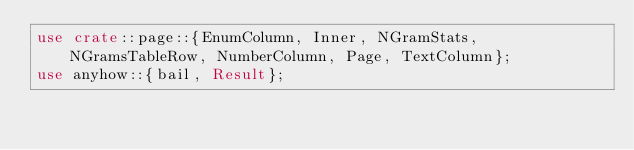Convert code to text. <code><loc_0><loc_0><loc_500><loc_500><_Rust_>use crate::page::{EnumColumn, Inner, NGramStats, NGramsTableRow, NumberColumn, Page, TextColumn};
use anyhow::{bail, Result};</code> 